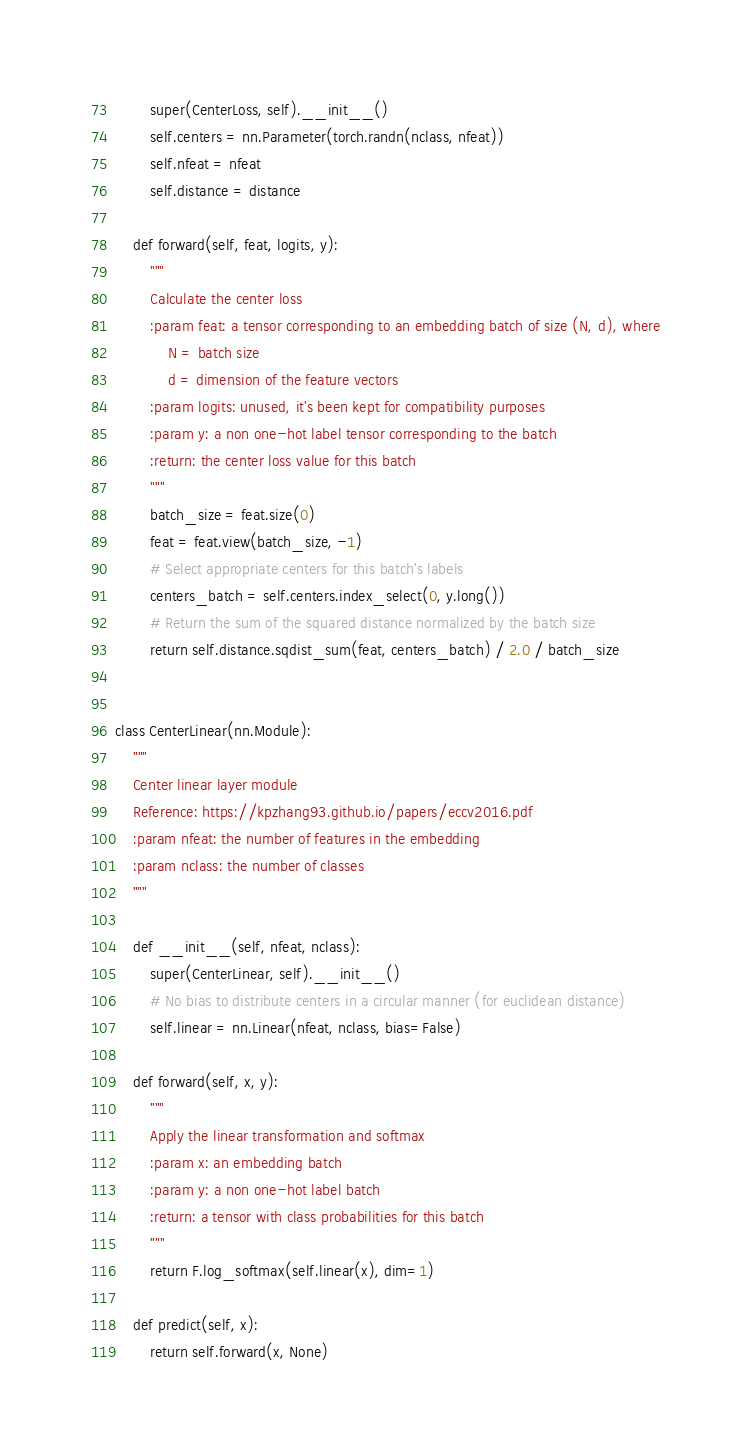<code> <loc_0><loc_0><loc_500><loc_500><_Python_>        super(CenterLoss, self).__init__()
        self.centers = nn.Parameter(torch.randn(nclass, nfeat))
        self.nfeat = nfeat
        self.distance = distance
    
    def forward(self, feat, logits, y):
        """
        Calculate the center loss
        :param feat: a tensor corresponding to an embedding batch of size (N, d), where
            N = batch size
            d = dimension of the feature vectors
        :param logits: unused, it's been kept for compatibility purposes
        :param y: a non one-hot label tensor corresponding to the batch
        :return: the center loss value for this batch
        """
        batch_size = feat.size(0)
        feat = feat.view(batch_size, -1)
        # Select appropriate centers for this batch's labels
        centers_batch = self.centers.index_select(0, y.long())
        # Return the sum of the squared distance normalized by the batch size
        return self.distance.sqdist_sum(feat, centers_batch) / 2.0 / batch_size


class CenterLinear(nn.Module):
    """
    Center linear layer module
    Reference: https://kpzhang93.github.io/papers/eccv2016.pdf
    :param nfeat: the number of features in the embedding
    :param nclass: the number of classes
    """
    
    def __init__(self, nfeat, nclass):
        super(CenterLinear, self).__init__()
        # No bias to distribute centers in a circular manner (for euclidean distance)
        self.linear = nn.Linear(nfeat, nclass, bias=False)
    
    def forward(self, x, y):
        """
        Apply the linear transformation and softmax
        :param x: an embedding batch
        :param y: a non one-hot label batch
        :return: a tensor with class probabilities for this batch
        """
        return F.log_softmax(self.linear(x), dim=1)

    def predict(self, x):
        return self.forward(x, None)
</code> 